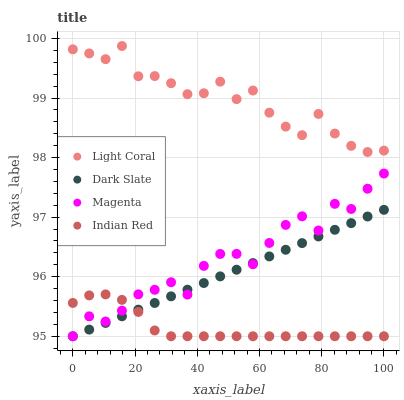Does Indian Red have the minimum area under the curve?
Answer yes or no. Yes. Does Light Coral have the maximum area under the curve?
Answer yes or no. Yes. Does Dark Slate have the minimum area under the curve?
Answer yes or no. No. Does Dark Slate have the maximum area under the curve?
Answer yes or no. No. Is Dark Slate the smoothest?
Answer yes or no. Yes. Is Magenta the roughest?
Answer yes or no. Yes. Is Magenta the smoothest?
Answer yes or no. No. Is Dark Slate the roughest?
Answer yes or no. No. Does Dark Slate have the lowest value?
Answer yes or no. Yes. Does Light Coral have the highest value?
Answer yes or no. Yes. Does Dark Slate have the highest value?
Answer yes or no. No. Is Indian Red less than Light Coral?
Answer yes or no. Yes. Is Light Coral greater than Dark Slate?
Answer yes or no. Yes. Does Magenta intersect Indian Red?
Answer yes or no. Yes. Is Magenta less than Indian Red?
Answer yes or no. No. Is Magenta greater than Indian Red?
Answer yes or no. No. Does Indian Red intersect Light Coral?
Answer yes or no. No. 